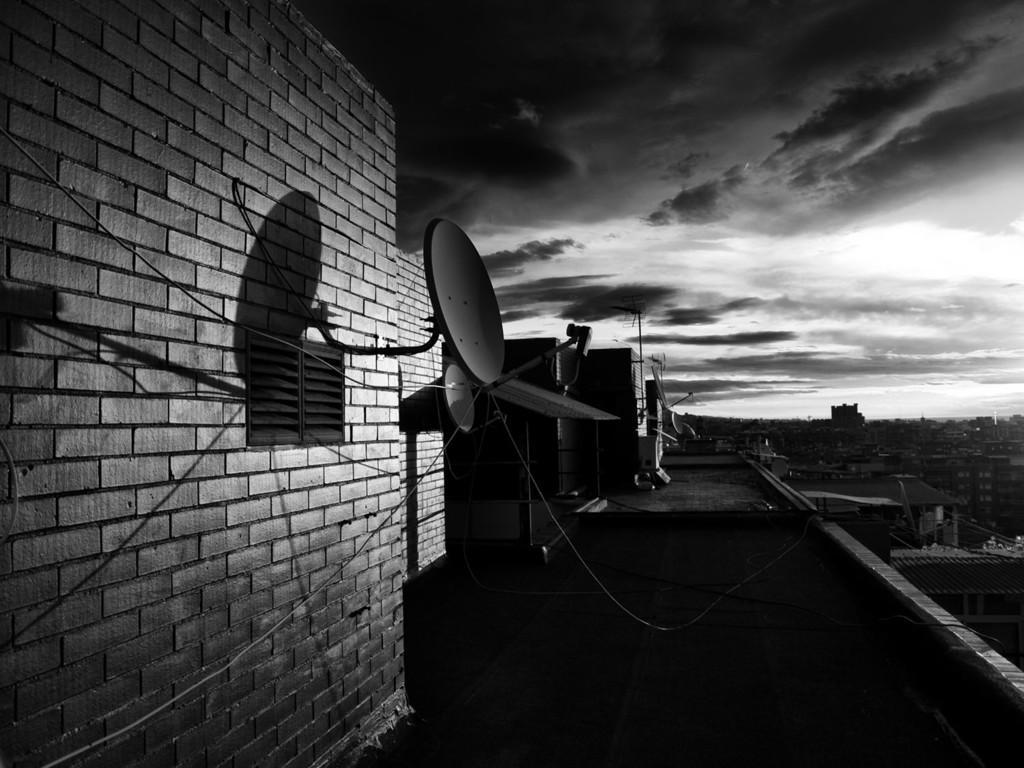Can you describe this image briefly? This is a black and white picture. At the bottom, we see the pavement. On the left side, we see the buildings, poles, cables and the satellite dishes. On the right side, we see the buildings. There are trees and the buildings in the background. At the top, we see the sky and the clouds. 